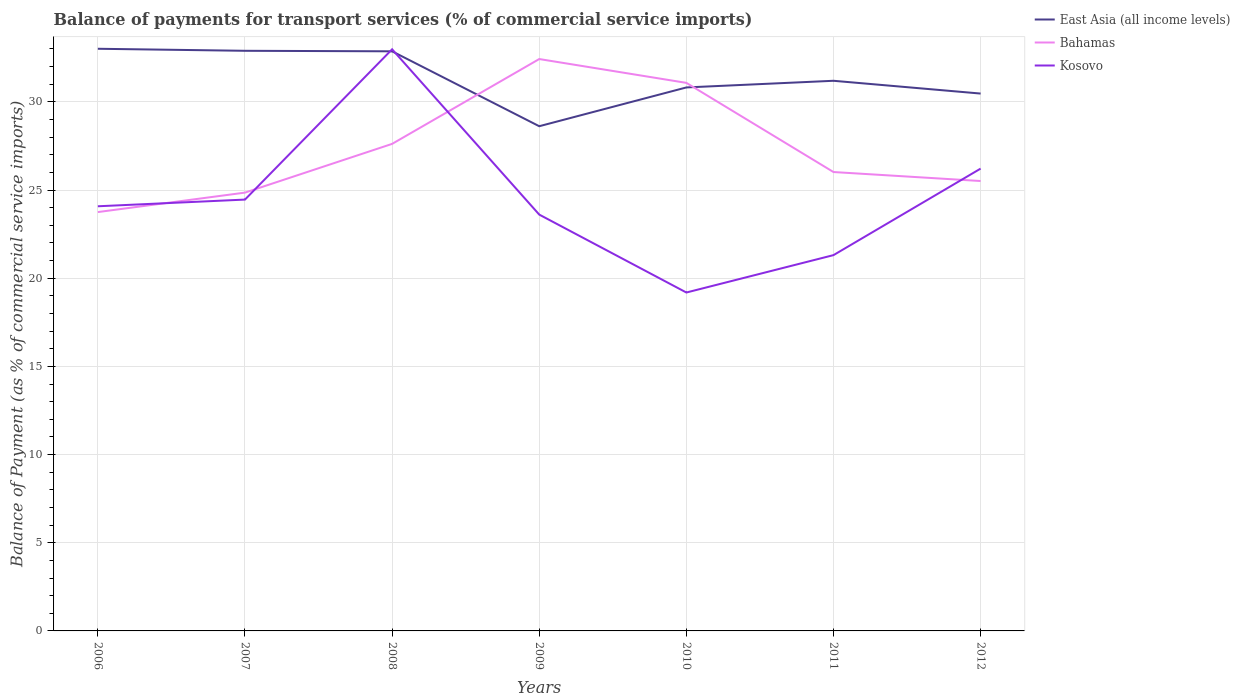Across all years, what is the maximum balance of payments for transport services in Bahamas?
Ensure brevity in your answer.  23.75. In which year was the balance of payments for transport services in Kosovo maximum?
Offer a very short reply. 2010. What is the total balance of payments for transport services in East Asia (all income levels) in the graph?
Keep it short and to the point. -1.85. What is the difference between the highest and the second highest balance of payments for transport services in Bahamas?
Provide a succinct answer. 8.68. Is the balance of payments for transport services in Kosovo strictly greater than the balance of payments for transport services in Bahamas over the years?
Provide a short and direct response. No. How many years are there in the graph?
Your answer should be very brief. 7. Does the graph contain grids?
Provide a succinct answer. Yes. How many legend labels are there?
Provide a short and direct response. 3. How are the legend labels stacked?
Your answer should be very brief. Vertical. What is the title of the graph?
Offer a very short reply. Balance of payments for transport services (% of commercial service imports). What is the label or title of the Y-axis?
Ensure brevity in your answer.  Balance of Payment (as % of commercial service imports). What is the Balance of Payment (as % of commercial service imports) of East Asia (all income levels) in 2006?
Your answer should be compact. 33.01. What is the Balance of Payment (as % of commercial service imports) of Bahamas in 2006?
Make the answer very short. 23.75. What is the Balance of Payment (as % of commercial service imports) in Kosovo in 2006?
Give a very brief answer. 24.08. What is the Balance of Payment (as % of commercial service imports) of East Asia (all income levels) in 2007?
Provide a short and direct response. 32.9. What is the Balance of Payment (as % of commercial service imports) in Bahamas in 2007?
Offer a very short reply. 24.85. What is the Balance of Payment (as % of commercial service imports) of Kosovo in 2007?
Offer a terse response. 24.46. What is the Balance of Payment (as % of commercial service imports) in East Asia (all income levels) in 2008?
Offer a very short reply. 32.87. What is the Balance of Payment (as % of commercial service imports) of Bahamas in 2008?
Give a very brief answer. 27.62. What is the Balance of Payment (as % of commercial service imports) of Kosovo in 2008?
Provide a succinct answer. 32.98. What is the Balance of Payment (as % of commercial service imports) in East Asia (all income levels) in 2009?
Offer a very short reply. 28.62. What is the Balance of Payment (as % of commercial service imports) in Bahamas in 2009?
Provide a succinct answer. 32.43. What is the Balance of Payment (as % of commercial service imports) in Kosovo in 2009?
Make the answer very short. 23.61. What is the Balance of Payment (as % of commercial service imports) in East Asia (all income levels) in 2010?
Provide a succinct answer. 30.82. What is the Balance of Payment (as % of commercial service imports) of Bahamas in 2010?
Provide a short and direct response. 31.08. What is the Balance of Payment (as % of commercial service imports) in Kosovo in 2010?
Make the answer very short. 19.19. What is the Balance of Payment (as % of commercial service imports) in East Asia (all income levels) in 2011?
Make the answer very short. 31.2. What is the Balance of Payment (as % of commercial service imports) of Bahamas in 2011?
Keep it short and to the point. 26.02. What is the Balance of Payment (as % of commercial service imports) of Kosovo in 2011?
Make the answer very short. 21.31. What is the Balance of Payment (as % of commercial service imports) of East Asia (all income levels) in 2012?
Ensure brevity in your answer.  30.47. What is the Balance of Payment (as % of commercial service imports) in Bahamas in 2012?
Offer a terse response. 25.51. What is the Balance of Payment (as % of commercial service imports) in Kosovo in 2012?
Your answer should be very brief. 26.21. Across all years, what is the maximum Balance of Payment (as % of commercial service imports) in East Asia (all income levels)?
Give a very brief answer. 33.01. Across all years, what is the maximum Balance of Payment (as % of commercial service imports) in Bahamas?
Provide a short and direct response. 32.43. Across all years, what is the maximum Balance of Payment (as % of commercial service imports) in Kosovo?
Your response must be concise. 32.98. Across all years, what is the minimum Balance of Payment (as % of commercial service imports) in East Asia (all income levels)?
Your answer should be compact. 28.62. Across all years, what is the minimum Balance of Payment (as % of commercial service imports) in Bahamas?
Offer a very short reply. 23.75. Across all years, what is the minimum Balance of Payment (as % of commercial service imports) in Kosovo?
Give a very brief answer. 19.19. What is the total Balance of Payment (as % of commercial service imports) in East Asia (all income levels) in the graph?
Your answer should be compact. 219.87. What is the total Balance of Payment (as % of commercial service imports) in Bahamas in the graph?
Ensure brevity in your answer.  191.26. What is the total Balance of Payment (as % of commercial service imports) of Kosovo in the graph?
Ensure brevity in your answer.  171.84. What is the difference between the Balance of Payment (as % of commercial service imports) of East Asia (all income levels) in 2006 and that in 2007?
Your answer should be very brief. 0.12. What is the difference between the Balance of Payment (as % of commercial service imports) of Bahamas in 2006 and that in 2007?
Your response must be concise. -1.1. What is the difference between the Balance of Payment (as % of commercial service imports) of Kosovo in 2006 and that in 2007?
Your answer should be very brief. -0.38. What is the difference between the Balance of Payment (as % of commercial service imports) of East Asia (all income levels) in 2006 and that in 2008?
Offer a very short reply. 0.14. What is the difference between the Balance of Payment (as % of commercial service imports) of Bahamas in 2006 and that in 2008?
Provide a succinct answer. -3.87. What is the difference between the Balance of Payment (as % of commercial service imports) in Kosovo in 2006 and that in 2008?
Your answer should be very brief. -8.9. What is the difference between the Balance of Payment (as % of commercial service imports) of East Asia (all income levels) in 2006 and that in 2009?
Make the answer very short. 4.39. What is the difference between the Balance of Payment (as % of commercial service imports) of Bahamas in 2006 and that in 2009?
Ensure brevity in your answer.  -8.68. What is the difference between the Balance of Payment (as % of commercial service imports) of Kosovo in 2006 and that in 2009?
Keep it short and to the point. 0.47. What is the difference between the Balance of Payment (as % of commercial service imports) in East Asia (all income levels) in 2006 and that in 2010?
Provide a short and direct response. 2.19. What is the difference between the Balance of Payment (as % of commercial service imports) in Bahamas in 2006 and that in 2010?
Your answer should be compact. -7.33. What is the difference between the Balance of Payment (as % of commercial service imports) of Kosovo in 2006 and that in 2010?
Your response must be concise. 4.89. What is the difference between the Balance of Payment (as % of commercial service imports) of East Asia (all income levels) in 2006 and that in 2011?
Offer a very short reply. 1.82. What is the difference between the Balance of Payment (as % of commercial service imports) in Bahamas in 2006 and that in 2011?
Offer a very short reply. -2.27. What is the difference between the Balance of Payment (as % of commercial service imports) of Kosovo in 2006 and that in 2011?
Offer a very short reply. 2.77. What is the difference between the Balance of Payment (as % of commercial service imports) of East Asia (all income levels) in 2006 and that in 2012?
Give a very brief answer. 2.54. What is the difference between the Balance of Payment (as % of commercial service imports) of Bahamas in 2006 and that in 2012?
Provide a short and direct response. -1.76. What is the difference between the Balance of Payment (as % of commercial service imports) of Kosovo in 2006 and that in 2012?
Give a very brief answer. -2.14. What is the difference between the Balance of Payment (as % of commercial service imports) in East Asia (all income levels) in 2007 and that in 2008?
Offer a terse response. 0.03. What is the difference between the Balance of Payment (as % of commercial service imports) in Bahamas in 2007 and that in 2008?
Give a very brief answer. -2.76. What is the difference between the Balance of Payment (as % of commercial service imports) of Kosovo in 2007 and that in 2008?
Give a very brief answer. -8.52. What is the difference between the Balance of Payment (as % of commercial service imports) in East Asia (all income levels) in 2007 and that in 2009?
Your answer should be compact. 4.28. What is the difference between the Balance of Payment (as % of commercial service imports) in Bahamas in 2007 and that in 2009?
Give a very brief answer. -7.57. What is the difference between the Balance of Payment (as % of commercial service imports) in Kosovo in 2007 and that in 2009?
Your answer should be compact. 0.85. What is the difference between the Balance of Payment (as % of commercial service imports) in East Asia (all income levels) in 2007 and that in 2010?
Provide a short and direct response. 2.08. What is the difference between the Balance of Payment (as % of commercial service imports) in Bahamas in 2007 and that in 2010?
Provide a short and direct response. -6.22. What is the difference between the Balance of Payment (as % of commercial service imports) in Kosovo in 2007 and that in 2010?
Provide a short and direct response. 5.27. What is the difference between the Balance of Payment (as % of commercial service imports) of East Asia (all income levels) in 2007 and that in 2011?
Ensure brevity in your answer.  1.7. What is the difference between the Balance of Payment (as % of commercial service imports) of Bahamas in 2007 and that in 2011?
Offer a very short reply. -1.17. What is the difference between the Balance of Payment (as % of commercial service imports) of Kosovo in 2007 and that in 2011?
Offer a terse response. 3.15. What is the difference between the Balance of Payment (as % of commercial service imports) of East Asia (all income levels) in 2007 and that in 2012?
Ensure brevity in your answer.  2.42. What is the difference between the Balance of Payment (as % of commercial service imports) in Bahamas in 2007 and that in 2012?
Make the answer very short. -0.66. What is the difference between the Balance of Payment (as % of commercial service imports) in Kosovo in 2007 and that in 2012?
Your answer should be very brief. -1.76. What is the difference between the Balance of Payment (as % of commercial service imports) in East Asia (all income levels) in 2008 and that in 2009?
Provide a succinct answer. 4.25. What is the difference between the Balance of Payment (as % of commercial service imports) of Bahamas in 2008 and that in 2009?
Your answer should be very brief. -4.81. What is the difference between the Balance of Payment (as % of commercial service imports) in Kosovo in 2008 and that in 2009?
Your answer should be compact. 9.37. What is the difference between the Balance of Payment (as % of commercial service imports) of East Asia (all income levels) in 2008 and that in 2010?
Your answer should be very brief. 2.05. What is the difference between the Balance of Payment (as % of commercial service imports) of Bahamas in 2008 and that in 2010?
Give a very brief answer. -3.46. What is the difference between the Balance of Payment (as % of commercial service imports) of Kosovo in 2008 and that in 2010?
Give a very brief answer. 13.79. What is the difference between the Balance of Payment (as % of commercial service imports) in East Asia (all income levels) in 2008 and that in 2011?
Your answer should be compact. 1.67. What is the difference between the Balance of Payment (as % of commercial service imports) in Bahamas in 2008 and that in 2011?
Make the answer very short. 1.6. What is the difference between the Balance of Payment (as % of commercial service imports) of Kosovo in 2008 and that in 2011?
Offer a terse response. 11.67. What is the difference between the Balance of Payment (as % of commercial service imports) of East Asia (all income levels) in 2008 and that in 2012?
Your answer should be compact. 2.4. What is the difference between the Balance of Payment (as % of commercial service imports) of Bahamas in 2008 and that in 2012?
Give a very brief answer. 2.11. What is the difference between the Balance of Payment (as % of commercial service imports) of Kosovo in 2008 and that in 2012?
Your answer should be very brief. 6.77. What is the difference between the Balance of Payment (as % of commercial service imports) of East Asia (all income levels) in 2009 and that in 2010?
Make the answer very short. -2.2. What is the difference between the Balance of Payment (as % of commercial service imports) of Bahamas in 2009 and that in 2010?
Offer a very short reply. 1.35. What is the difference between the Balance of Payment (as % of commercial service imports) of Kosovo in 2009 and that in 2010?
Ensure brevity in your answer.  4.42. What is the difference between the Balance of Payment (as % of commercial service imports) of East Asia (all income levels) in 2009 and that in 2011?
Keep it short and to the point. -2.58. What is the difference between the Balance of Payment (as % of commercial service imports) of Bahamas in 2009 and that in 2011?
Offer a very short reply. 6.41. What is the difference between the Balance of Payment (as % of commercial service imports) in Kosovo in 2009 and that in 2011?
Offer a very short reply. 2.3. What is the difference between the Balance of Payment (as % of commercial service imports) in East Asia (all income levels) in 2009 and that in 2012?
Provide a succinct answer. -1.85. What is the difference between the Balance of Payment (as % of commercial service imports) in Bahamas in 2009 and that in 2012?
Provide a short and direct response. 6.92. What is the difference between the Balance of Payment (as % of commercial service imports) of Kosovo in 2009 and that in 2012?
Provide a succinct answer. -2.61. What is the difference between the Balance of Payment (as % of commercial service imports) in East Asia (all income levels) in 2010 and that in 2011?
Make the answer very short. -0.38. What is the difference between the Balance of Payment (as % of commercial service imports) in Bahamas in 2010 and that in 2011?
Make the answer very short. 5.06. What is the difference between the Balance of Payment (as % of commercial service imports) in Kosovo in 2010 and that in 2011?
Your response must be concise. -2.12. What is the difference between the Balance of Payment (as % of commercial service imports) of East Asia (all income levels) in 2010 and that in 2012?
Ensure brevity in your answer.  0.35. What is the difference between the Balance of Payment (as % of commercial service imports) of Bahamas in 2010 and that in 2012?
Your response must be concise. 5.57. What is the difference between the Balance of Payment (as % of commercial service imports) of Kosovo in 2010 and that in 2012?
Your answer should be very brief. -7.03. What is the difference between the Balance of Payment (as % of commercial service imports) of East Asia (all income levels) in 2011 and that in 2012?
Give a very brief answer. 0.72. What is the difference between the Balance of Payment (as % of commercial service imports) in Bahamas in 2011 and that in 2012?
Make the answer very short. 0.51. What is the difference between the Balance of Payment (as % of commercial service imports) in Kosovo in 2011 and that in 2012?
Ensure brevity in your answer.  -4.91. What is the difference between the Balance of Payment (as % of commercial service imports) of East Asia (all income levels) in 2006 and the Balance of Payment (as % of commercial service imports) of Bahamas in 2007?
Provide a succinct answer. 8.16. What is the difference between the Balance of Payment (as % of commercial service imports) of East Asia (all income levels) in 2006 and the Balance of Payment (as % of commercial service imports) of Kosovo in 2007?
Your answer should be compact. 8.55. What is the difference between the Balance of Payment (as % of commercial service imports) in Bahamas in 2006 and the Balance of Payment (as % of commercial service imports) in Kosovo in 2007?
Your response must be concise. -0.71. What is the difference between the Balance of Payment (as % of commercial service imports) in East Asia (all income levels) in 2006 and the Balance of Payment (as % of commercial service imports) in Bahamas in 2008?
Your answer should be compact. 5.39. What is the difference between the Balance of Payment (as % of commercial service imports) of East Asia (all income levels) in 2006 and the Balance of Payment (as % of commercial service imports) of Kosovo in 2008?
Make the answer very short. 0.03. What is the difference between the Balance of Payment (as % of commercial service imports) in Bahamas in 2006 and the Balance of Payment (as % of commercial service imports) in Kosovo in 2008?
Offer a very short reply. -9.23. What is the difference between the Balance of Payment (as % of commercial service imports) in East Asia (all income levels) in 2006 and the Balance of Payment (as % of commercial service imports) in Bahamas in 2009?
Give a very brief answer. 0.58. What is the difference between the Balance of Payment (as % of commercial service imports) in East Asia (all income levels) in 2006 and the Balance of Payment (as % of commercial service imports) in Kosovo in 2009?
Offer a very short reply. 9.4. What is the difference between the Balance of Payment (as % of commercial service imports) of Bahamas in 2006 and the Balance of Payment (as % of commercial service imports) of Kosovo in 2009?
Offer a terse response. 0.14. What is the difference between the Balance of Payment (as % of commercial service imports) of East Asia (all income levels) in 2006 and the Balance of Payment (as % of commercial service imports) of Bahamas in 2010?
Keep it short and to the point. 1.93. What is the difference between the Balance of Payment (as % of commercial service imports) in East Asia (all income levels) in 2006 and the Balance of Payment (as % of commercial service imports) in Kosovo in 2010?
Your response must be concise. 13.82. What is the difference between the Balance of Payment (as % of commercial service imports) in Bahamas in 2006 and the Balance of Payment (as % of commercial service imports) in Kosovo in 2010?
Offer a very short reply. 4.56. What is the difference between the Balance of Payment (as % of commercial service imports) in East Asia (all income levels) in 2006 and the Balance of Payment (as % of commercial service imports) in Bahamas in 2011?
Your answer should be compact. 6.99. What is the difference between the Balance of Payment (as % of commercial service imports) in East Asia (all income levels) in 2006 and the Balance of Payment (as % of commercial service imports) in Kosovo in 2011?
Give a very brief answer. 11.7. What is the difference between the Balance of Payment (as % of commercial service imports) of Bahamas in 2006 and the Balance of Payment (as % of commercial service imports) of Kosovo in 2011?
Keep it short and to the point. 2.44. What is the difference between the Balance of Payment (as % of commercial service imports) in East Asia (all income levels) in 2006 and the Balance of Payment (as % of commercial service imports) in Bahamas in 2012?
Ensure brevity in your answer.  7.5. What is the difference between the Balance of Payment (as % of commercial service imports) in East Asia (all income levels) in 2006 and the Balance of Payment (as % of commercial service imports) in Kosovo in 2012?
Provide a short and direct response. 6.8. What is the difference between the Balance of Payment (as % of commercial service imports) in Bahamas in 2006 and the Balance of Payment (as % of commercial service imports) in Kosovo in 2012?
Ensure brevity in your answer.  -2.46. What is the difference between the Balance of Payment (as % of commercial service imports) in East Asia (all income levels) in 2007 and the Balance of Payment (as % of commercial service imports) in Bahamas in 2008?
Your answer should be very brief. 5.28. What is the difference between the Balance of Payment (as % of commercial service imports) in East Asia (all income levels) in 2007 and the Balance of Payment (as % of commercial service imports) in Kosovo in 2008?
Your answer should be very brief. -0.08. What is the difference between the Balance of Payment (as % of commercial service imports) in Bahamas in 2007 and the Balance of Payment (as % of commercial service imports) in Kosovo in 2008?
Offer a terse response. -8.13. What is the difference between the Balance of Payment (as % of commercial service imports) of East Asia (all income levels) in 2007 and the Balance of Payment (as % of commercial service imports) of Bahamas in 2009?
Provide a short and direct response. 0.47. What is the difference between the Balance of Payment (as % of commercial service imports) in East Asia (all income levels) in 2007 and the Balance of Payment (as % of commercial service imports) in Kosovo in 2009?
Your answer should be very brief. 9.29. What is the difference between the Balance of Payment (as % of commercial service imports) of Bahamas in 2007 and the Balance of Payment (as % of commercial service imports) of Kosovo in 2009?
Give a very brief answer. 1.25. What is the difference between the Balance of Payment (as % of commercial service imports) of East Asia (all income levels) in 2007 and the Balance of Payment (as % of commercial service imports) of Bahamas in 2010?
Keep it short and to the point. 1.82. What is the difference between the Balance of Payment (as % of commercial service imports) in East Asia (all income levels) in 2007 and the Balance of Payment (as % of commercial service imports) in Kosovo in 2010?
Provide a short and direct response. 13.71. What is the difference between the Balance of Payment (as % of commercial service imports) in Bahamas in 2007 and the Balance of Payment (as % of commercial service imports) in Kosovo in 2010?
Offer a very short reply. 5.66. What is the difference between the Balance of Payment (as % of commercial service imports) of East Asia (all income levels) in 2007 and the Balance of Payment (as % of commercial service imports) of Bahamas in 2011?
Provide a succinct answer. 6.87. What is the difference between the Balance of Payment (as % of commercial service imports) of East Asia (all income levels) in 2007 and the Balance of Payment (as % of commercial service imports) of Kosovo in 2011?
Offer a very short reply. 11.59. What is the difference between the Balance of Payment (as % of commercial service imports) of Bahamas in 2007 and the Balance of Payment (as % of commercial service imports) of Kosovo in 2011?
Make the answer very short. 3.54. What is the difference between the Balance of Payment (as % of commercial service imports) of East Asia (all income levels) in 2007 and the Balance of Payment (as % of commercial service imports) of Bahamas in 2012?
Offer a terse response. 7.38. What is the difference between the Balance of Payment (as % of commercial service imports) in East Asia (all income levels) in 2007 and the Balance of Payment (as % of commercial service imports) in Kosovo in 2012?
Offer a very short reply. 6.68. What is the difference between the Balance of Payment (as % of commercial service imports) of Bahamas in 2007 and the Balance of Payment (as % of commercial service imports) of Kosovo in 2012?
Make the answer very short. -1.36. What is the difference between the Balance of Payment (as % of commercial service imports) of East Asia (all income levels) in 2008 and the Balance of Payment (as % of commercial service imports) of Bahamas in 2009?
Give a very brief answer. 0.44. What is the difference between the Balance of Payment (as % of commercial service imports) of East Asia (all income levels) in 2008 and the Balance of Payment (as % of commercial service imports) of Kosovo in 2009?
Provide a succinct answer. 9.26. What is the difference between the Balance of Payment (as % of commercial service imports) in Bahamas in 2008 and the Balance of Payment (as % of commercial service imports) in Kosovo in 2009?
Your response must be concise. 4.01. What is the difference between the Balance of Payment (as % of commercial service imports) in East Asia (all income levels) in 2008 and the Balance of Payment (as % of commercial service imports) in Bahamas in 2010?
Your response must be concise. 1.79. What is the difference between the Balance of Payment (as % of commercial service imports) of East Asia (all income levels) in 2008 and the Balance of Payment (as % of commercial service imports) of Kosovo in 2010?
Offer a terse response. 13.68. What is the difference between the Balance of Payment (as % of commercial service imports) in Bahamas in 2008 and the Balance of Payment (as % of commercial service imports) in Kosovo in 2010?
Your answer should be very brief. 8.43. What is the difference between the Balance of Payment (as % of commercial service imports) in East Asia (all income levels) in 2008 and the Balance of Payment (as % of commercial service imports) in Bahamas in 2011?
Keep it short and to the point. 6.85. What is the difference between the Balance of Payment (as % of commercial service imports) of East Asia (all income levels) in 2008 and the Balance of Payment (as % of commercial service imports) of Kosovo in 2011?
Your answer should be very brief. 11.56. What is the difference between the Balance of Payment (as % of commercial service imports) in Bahamas in 2008 and the Balance of Payment (as % of commercial service imports) in Kosovo in 2011?
Ensure brevity in your answer.  6.31. What is the difference between the Balance of Payment (as % of commercial service imports) of East Asia (all income levels) in 2008 and the Balance of Payment (as % of commercial service imports) of Bahamas in 2012?
Your response must be concise. 7.35. What is the difference between the Balance of Payment (as % of commercial service imports) in East Asia (all income levels) in 2008 and the Balance of Payment (as % of commercial service imports) in Kosovo in 2012?
Your response must be concise. 6.65. What is the difference between the Balance of Payment (as % of commercial service imports) of Bahamas in 2008 and the Balance of Payment (as % of commercial service imports) of Kosovo in 2012?
Make the answer very short. 1.4. What is the difference between the Balance of Payment (as % of commercial service imports) in East Asia (all income levels) in 2009 and the Balance of Payment (as % of commercial service imports) in Bahamas in 2010?
Keep it short and to the point. -2.46. What is the difference between the Balance of Payment (as % of commercial service imports) of East Asia (all income levels) in 2009 and the Balance of Payment (as % of commercial service imports) of Kosovo in 2010?
Your answer should be compact. 9.43. What is the difference between the Balance of Payment (as % of commercial service imports) of Bahamas in 2009 and the Balance of Payment (as % of commercial service imports) of Kosovo in 2010?
Ensure brevity in your answer.  13.24. What is the difference between the Balance of Payment (as % of commercial service imports) of East Asia (all income levels) in 2009 and the Balance of Payment (as % of commercial service imports) of Bahamas in 2011?
Keep it short and to the point. 2.6. What is the difference between the Balance of Payment (as % of commercial service imports) in East Asia (all income levels) in 2009 and the Balance of Payment (as % of commercial service imports) in Kosovo in 2011?
Provide a short and direct response. 7.31. What is the difference between the Balance of Payment (as % of commercial service imports) of Bahamas in 2009 and the Balance of Payment (as % of commercial service imports) of Kosovo in 2011?
Your answer should be very brief. 11.12. What is the difference between the Balance of Payment (as % of commercial service imports) in East Asia (all income levels) in 2009 and the Balance of Payment (as % of commercial service imports) in Bahamas in 2012?
Make the answer very short. 3.11. What is the difference between the Balance of Payment (as % of commercial service imports) in East Asia (all income levels) in 2009 and the Balance of Payment (as % of commercial service imports) in Kosovo in 2012?
Offer a very short reply. 2.4. What is the difference between the Balance of Payment (as % of commercial service imports) in Bahamas in 2009 and the Balance of Payment (as % of commercial service imports) in Kosovo in 2012?
Keep it short and to the point. 6.21. What is the difference between the Balance of Payment (as % of commercial service imports) of East Asia (all income levels) in 2010 and the Balance of Payment (as % of commercial service imports) of Bahamas in 2011?
Your answer should be very brief. 4.8. What is the difference between the Balance of Payment (as % of commercial service imports) of East Asia (all income levels) in 2010 and the Balance of Payment (as % of commercial service imports) of Kosovo in 2011?
Provide a short and direct response. 9.51. What is the difference between the Balance of Payment (as % of commercial service imports) of Bahamas in 2010 and the Balance of Payment (as % of commercial service imports) of Kosovo in 2011?
Your answer should be compact. 9.77. What is the difference between the Balance of Payment (as % of commercial service imports) in East Asia (all income levels) in 2010 and the Balance of Payment (as % of commercial service imports) in Bahamas in 2012?
Offer a terse response. 5.31. What is the difference between the Balance of Payment (as % of commercial service imports) of East Asia (all income levels) in 2010 and the Balance of Payment (as % of commercial service imports) of Kosovo in 2012?
Your response must be concise. 4.6. What is the difference between the Balance of Payment (as % of commercial service imports) of Bahamas in 2010 and the Balance of Payment (as % of commercial service imports) of Kosovo in 2012?
Offer a terse response. 4.86. What is the difference between the Balance of Payment (as % of commercial service imports) in East Asia (all income levels) in 2011 and the Balance of Payment (as % of commercial service imports) in Bahamas in 2012?
Keep it short and to the point. 5.68. What is the difference between the Balance of Payment (as % of commercial service imports) in East Asia (all income levels) in 2011 and the Balance of Payment (as % of commercial service imports) in Kosovo in 2012?
Make the answer very short. 4.98. What is the difference between the Balance of Payment (as % of commercial service imports) in Bahamas in 2011 and the Balance of Payment (as % of commercial service imports) in Kosovo in 2012?
Ensure brevity in your answer.  -0.19. What is the average Balance of Payment (as % of commercial service imports) of East Asia (all income levels) per year?
Make the answer very short. 31.41. What is the average Balance of Payment (as % of commercial service imports) of Bahamas per year?
Offer a terse response. 27.32. What is the average Balance of Payment (as % of commercial service imports) of Kosovo per year?
Ensure brevity in your answer.  24.55. In the year 2006, what is the difference between the Balance of Payment (as % of commercial service imports) in East Asia (all income levels) and Balance of Payment (as % of commercial service imports) in Bahamas?
Make the answer very short. 9.26. In the year 2006, what is the difference between the Balance of Payment (as % of commercial service imports) in East Asia (all income levels) and Balance of Payment (as % of commercial service imports) in Kosovo?
Give a very brief answer. 8.93. In the year 2006, what is the difference between the Balance of Payment (as % of commercial service imports) in Bahamas and Balance of Payment (as % of commercial service imports) in Kosovo?
Give a very brief answer. -0.33. In the year 2007, what is the difference between the Balance of Payment (as % of commercial service imports) of East Asia (all income levels) and Balance of Payment (as % of commercial service imports) of Bahamas?
Offer a very short reply. 8.04. In the year 2007, what is the difference between the Balance of Payment (as % of commercial service imports) in East Asia (all income levels) and Balance of Payment (as % of commercial service imports) in Kosovo?
Make the answer very short. 8.44. In the year 2007, what is the difference between the Balance of Payment (as % of commercial service imports) of Bahamas and Balance of Payment (as % of commercial service imports) of Kosovo?
Give a very brief answer. 0.4. In the year 2008, what is the difference between the Balance of Payment (as % of commercial service imports) of East Asia (all income levels) and Balance of Payment (as % of commercial service imports) of Bahamas?
Ensure brevity in your answer.  5.25. In the year 2008, what is the difference between the Balance of Payment (as % of commercial service imports) in East Asia (all income levels) and Balance of Payment (as % of commercial service imports) in Kosovo?
Offer a very short reply. -0.11. In the year 2008, what is the difference between the Balance of Payment (as % of commercial service imports) of Bahamas and Balance of Payment (as % of commercial service imports) of Kosovo?
Offer a very short reply. -5.36. In the year 2009, what is the difference between the Balance of Payment (as % of commercial service imports) of East Asia (all income levels) and Balance of Payment (as % of commercial service imports) of Bahamas?
Offer a very short reply. -3.81. In the year 2009, what is the difference between the Balance of Payment (as % of commercial service imports) of East Asia (all income levels) and Balance of Payment (as % of commercial service imports) of Kosovo?
Ensure brevity in your answer.  5.01. In the year 2009, what is the difference between the Balance of Payment (as % of commercial service imports) of Bahamas and Balance of Payment (as % of commercial service imports) of Kosovo?
Your response must be concise. 8.82. In the year 2010, what is the difference between the Balance of Payment (as % of commercial service imports) in East Asia (all income levels) and Balance of Payment (as % of commercial service imports) in Bahamas?
Ensure brevity in your answer.  -0.26. In the year 2010, what is the difference between the Balance of Payment (as % of commercial service imports) in East Asia (all income levels) and Balance of Payment (as % of commercial service imports) in Kosovo?
Keep it short and to the point. 11.63. In the year 2010, what is the difference between the Balance of Payment (as % of commercial service imports) in Bahamas and Balance of Payment (as % of commercial service imports) in Kosovo?
Make the answer very short. 11.89. In the year 2011, what is the difference between the Balance of Payment (as % of commercial service imports) of East Asia (all income levels) and Balance of Payment (as % of commercial service imports) of Bahamas?
Provide a succinct answer. 5.17. In the year 2011, what is the difference between the Balance of Payment (as % of commercial service imports) of East Asia (all income levels) and Balance of Payment (as % of commercial service imports) of Kosovo?
Your answer should be compact. 9.89. In the year 2011, what is the difference between the Balance of Payment (as % of commercial service imports) of Bahamas and Balance of Payment (as % of commercial service imports) of Kosovo?
Offer a very short reply. 4.71. In the year 2012, what is the difference between the Balance of Payment (as % of commercial service imports) in East Asia (all income levels) and Balance of Payment (as % of commercial service imports) in Bahamas?
Keep it short and to the point. 4.96. In the year 2012, what is the difference between the Balance of Payment (as % of commercial service imports) of East Asia (all income levels) and Balance of Payment (as % of commercial service imports) of Kosovo?
Offer a terse response. 4.26. In the year 2012, what is the difference between the Balance of Payment (as % of commercial service imports) of Bahamas and Balance of Payment (as % of commercial service imports) of Kosovo?
Give a very brief answer. -0.7. What is the ratio of the Balance of Payment (as % of commercial service imports) of Bahamas in 2006 to that in 2007?
Make the answer very short. 0.96. What is the ratio of the Balance of Payment (as % of commercial service imports) of Kosovo in 2006 to that in 2007?
Offer a terse response. 0.98. What is the ratio of the Balance of Payment (as % of commercial service imports) in Bahamas in 2006 to that in 2008?
Your answer should be very brief. 0.86. What is the ratio of the Balance of Payment (as % of commercial service imports) in Kosovo in 2006 to that in 2008?
Ensure brevity in your answer.  0.73. What is the ratio of the Balance of Payment (as % of commercial service imports) in East Asia (all income levels) in 2006 to that in 2009?
Offer a terse response. 1.15. What is the ratio of the Balance of Payment (as % of commercial service imports) in Bahamas in 2006 to that in 2009?
Your answer should be compact. 0.73. What is the ratio of the Balance of Payment (as % of commercial service imports) in Kosovo in 2006 to that in 2009?
Keep it short and to the point. 1.02. What is the ratio of the Balance of Payment (as % of commercial service imports) of East Asia (all income levels) in 2006 to that in 2010?
Make the answer very short. 1.07. What is the ratio of the Balance of Payment (as % of commercial service imports) of Bahamas in 2006 to that in 2010?
Provide a succinct answer. 0.76. What is the ratio of the Balance of Payment (as % of commercial service imports) of Kosovo in 2006 to that in 2010?
Your answer should be very brief. 1.25. What is the ratio of the Balance of Payment (as % of commercial service imports) of East Asia (all income levels) in 2006 to that in 2011?
Your response must be concise. 1.06. What is the ratio of the Balance of Payment (as % of commercial service imports) of Bahamas in 2006 to that in 2011?
Your answer should be very brief. 0.91. What is the ratio of the Balance of Payment (as % of commercial service imports) in Kosovo in 2006 to that in 2011?
Keep it short and to the point. 1.13. What is the ratio of the Balance of Payment (as % of commercial service imports) in East Asia (all income levels) in 2006 to that in 2012?
Give a very brief answer. 1.08. What is the ratio of the Balance of Payment (as % of commercial service imports) of Kosovo in 2006 to that in 2012?
Provide a short and direct response. 0.92. What is the ratio of the Balance of Payment (as % of commercial service imports) in Bahamas in 2007 to that in 2008?
Offer a very short reply. 0.9. What is the ratio of the Balance of Payment (as % of commercial service imports) in Kosovo in 2007 to that in 2008?
Give a very brief answer. 0.74. What is the ratio of the Balance of Payment (as % of commercial service imports) in East Asia (all income levels) in 2007 to that in 2009?
Ensure brevity in your answer.  1.15. What is the ratio of the Balance of Payment (as % of commercial service imports) of Bahamas in 2007 to that in 2009?
Provide a short and direct response. 0.77. What is the ratio of the Balance of Payment (as % of commercial service imports) of Kosovo in 2007 to that in 2009?
Provide a short and direct response. 1.04. What is the ratio of the Balance of Payment (as % of commercial service imports) in East Asia (all income levels) in 2007 to that in 2010?
Make the answer very short. 1.07. What is the ratio of the Balance of Payment (as % of commercial service imports) in Bahamas in 2007 to that in 2010?
Your answer should be compact. 0.8. What is the ratio of the Balance of Payment (as % of commercial service imports) in Kosovo in 2007 to that in 2010?
Keep it short and to the point. 1.27. What is the ratio of the Balance of Payment (as % of commercial service imports) of East Asia (all income levels) in 2007 to that in 2011?
Ensure brevity in your answer.  1.05. What is the ratio of the Balance of Payment (as % of commercial service imports) of Bahamas in 2007 to that in 2011?
Ensure brevity in your answer.  0.96. What is the ratio of the Balance of Payment (as % of commercial service imports) of Kosovo in 2007 to that in 2011?
Provide a short and direct response. 1.15. What is the ratio of the Balance of Payment (as % of commercial service imports) in East Asia (all income levels) in 2007 to that in 2012?
Provide a short and direct response. 1.08. What is the ratio of the Balance of Payment (as % of commercial service imports) of Bahamas in 2007 to that in 2012?
Offer a terse response. 0.97. What is the ratio of the Balance of Payment (as % of commercial service imports) of Kosovo in 2007 to that in 2012?
Provide a short and direct response. 0.93. What is the ratio of the Balance of Payment (as % of commercial service imports) of East Asia (all income levels) in 2008 to that in 2009?
Offer a very short reply. 1.15. What is the ratio of the Balance of Payment (as % of commercial service imports) in Bahamas in 2008 to that in 2009?
Provide a short and direct response. 0.85. What is the ratio of the Balance of Payment (as % of commercial service imports) in Kosovo in 2008 to that in 2009?
Make the answer very short. 1.4. What is the ratio of the Balance of Payment (as % of commercial service imports) in East Asia (all income levels) in 2008 to that in 2010?
Your answer should be compact. 1.07. What is the ratio of the Balance of Payment (as % of commercial service imports) in Bahamas in 2008 to that in 2010?
Offer a very short reply. 0.89. What is the ratio of the Balance of Payment (as % of commercial service imports) in Kosovo in 2008 to that in 2010?
Ensure brevity in your answer.  1.72. What is the ratio of the Balance of Payment (as % of commercial service imports) of East Asia (all income levels) in 2008 to that in 2011?
Your answer should be compact. 1.05. What is the ratio of the Balance of Payment (as % of commercial service imports) in Bahamas in 2008 to that in 2011?
Provide a succinct answer. 1.06. What is the ratio of the Balance of Payment (as % of commercial service imports) in Kosovo in 2008 to that in 2011?
Offer a terse response. 1.55. What is the ratio of the Balance of Payment (as % of commercial service imports) of East Asia (all income levels) in 2008 to that in 2012?
Keep it short and to the point. 1.08. What is the ratio of the Balance of Payment (as % of commercial service imports) in Bahamas in 2008 to that in 2012?
Provide a succinct answer. 1.08. What is the ratio of the Balance of Payment (as % of commercial service imports) of Kosovo in 2008 to that in 2012?
Keep it short and to the point. 1.26. What is the ratio of the Balance of Payment (as % of commercial service imports) of East Asia (all income levels) in 2009 to that in 2010?
Provide a short and direct response. 0.93. What is the ratio of the Balance of Payment (as % of commercial service imports) in Bahamas in 2009 to that in 2010?
Keep it short and to the point. 1.04. What is the ratio of the Balance of Payment (as % of commercial service imports) of Kosovo in 2009 to that in 2010?
Provide a short and direct response. 1.23. What is the ratio of the Balance of Payment (as % of commercial service imports) of East Asia (all income levels) in 2009 to that in 2011?
Give a very brief answer. 0.92. What is the ratio of the Balance of Payment (as % of commercial service imports) in Bahamas in 2009 to that in 2011?
Provide a succinct answer. 1.25. What is the ratio of the Balance of Payment (as % of commercial service imports) in Kosovo in 2009 to that in 2011?
Offer a terse response. 1.11. What is the ratio of the Balance of Payment (as % of commercial service imports) in East Asia (all income levels) in 2009 to that in 2012?
Your answer should be very brief. 0.94. What is the ratio of the Balance of Payment (as % of commercial service imports) in Bahamas in 2009 to that in 2012?
Your response must be concise. 1.27. What is the ratio of the Balance of Payment (as % of commercial service imports) in Kosovo in 2009 to that in 2012?
Your response must be concise. 0.9. What is the ratio of the Balance of Payment (as % of commercial service imports) of East Asia (all income levels) in 2010 to that in 2011?
Your answer should be compact. 0.99. What is the ratio of the Balance of Payment (as % of commercial service imports) in Bahamas in 2010 to that in 2011?
Give a very brief answer. 1.19. What is the ratio of the Balance of Payment (as % of commercial service imports) in Kosovo in 2010 to that in 2011?
Ensure brevity in your answer.  0.9. What is the ratio of the Balance of Payment (as % of commercial service imports) in East Asia (all income levels) in 2010 to that in 2012?
Give a very brief answer. 1.01. What is the ratio of the Balance of Payment (as % of commercial service imports) in Bahamas in 2010 to that in 2012?
Offer a terse response. 1.22. What is the ratio of the Balance of Payment (as % of commercial service imports) of Kosovo in 2010 to that in 2012?
Your response must be concise. 0.73. What is the ratio of the Balance of Payment (as % of commercial service imports) in East Asia (all income levels) in 2011 to that in 2012?
Provide a short and direct response. 1.02. What is the ratio of the Balance of Payment (as % of commercial service imports) of Bahamas in 2011 to that in 2012?
Keep it short and to the point. 1.02. What is the ratio of the Balance of Payment (as % of commercial service imports) in Kosovo in 2011 to that in 2012?
Offer a terse response. 0.81. What is the difference between the highest and the second highest Balance of Payment (as % of commercial service imports) of East Asia (all income levels)?
Your response must be concise. 0.12. What is the difference between the highest and the second highest Balance of Payment (as % of commercial service imports) of Bahamas?
Your response must be concise. 1.35. What is the difference between the highest and the second highest Balance of Payment (as % of commercial service imports) in Kosovo?
Make the answer very short. 6.77. What is the difference between the highest and the lowest Balance of Payment (as % of commercial service imports) of East Asia (all income levels)?
Offer a terse response. 4.39. What is the difference between the highest and the lowest Balance of Payment (as % of commercial service imports) in Bahamas?
Keep it short and to the point. 8.68. What is the difference between the highest and the lowest Balance of Payment (as % of commercial service imports) of Kosovo?
Provide a succinct answer. 13.79. 